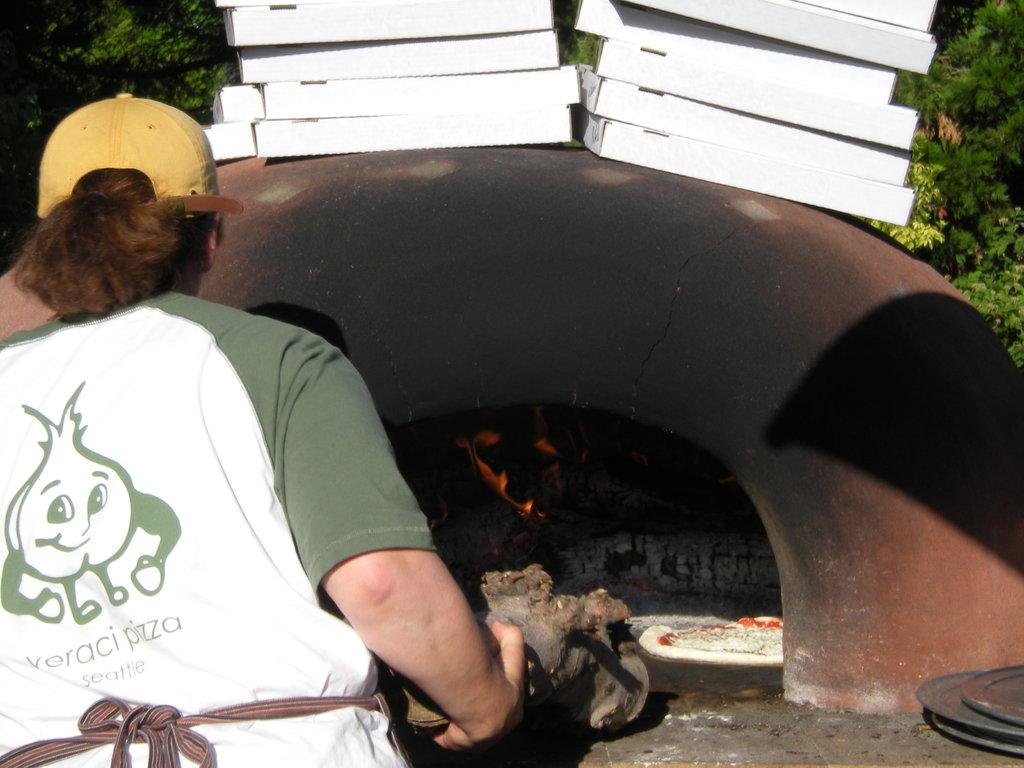Provide a one-sentence caption for the provided image. An employee of Veraci Pizza Seattle making a pizza in an outdoor oven. 